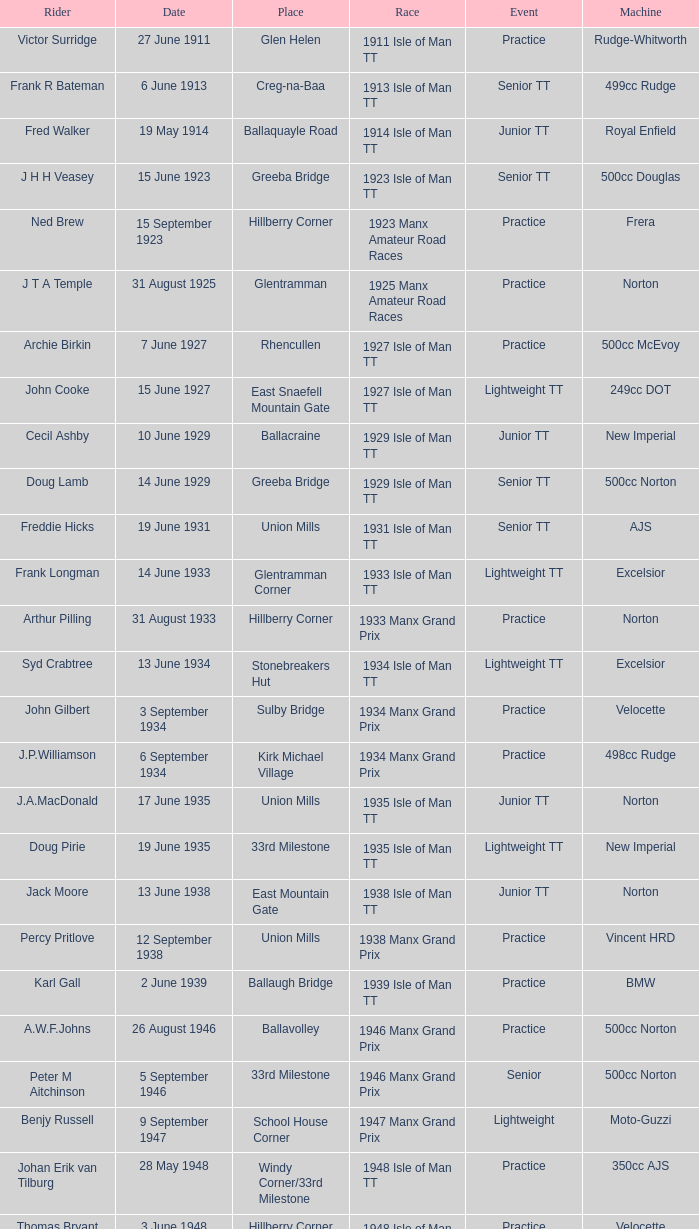What apparatus did kenneth e. herbert operate? 499cc Norton. 